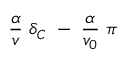Convert formula to latex. <formula><loc_0><loc_0><loc_500><loc_500>\frac { \alpha } { v } \ \delta _ { C } \ - \ \frac { \alpha } { v _ { 0 } } \ \pi</formula> 